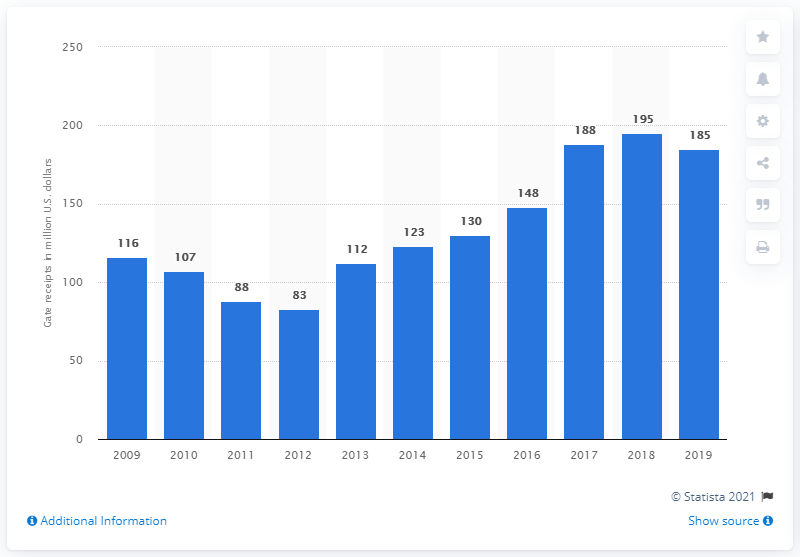Identify some key points in this picture. In 2019, the gate receipts of the Los Angeles Dodgers totaled 185 million dollars. 